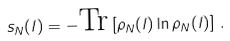Convert formula to latex. <formula><loc_0><loc_0><loc_500><loc_500>s _ { N } ( l ) = - { \text {Tr} } \left [ \rho _ { N } ( l ) \ln \rho _ { N } ( l ) \right ] \, .</formula> 